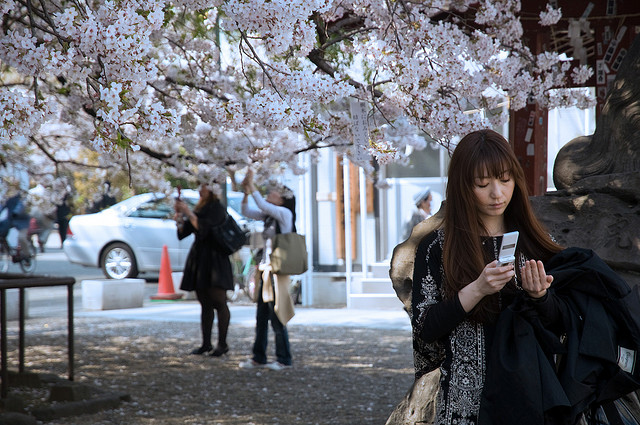<image>What are the objects behind the post? It is unclear what the objects behind the post are. They could be trees, buildings, or people. What are the objects behind the post? I don't know what objects are behind the post. It can be trees, buildings, barriers or unknown. 